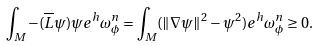Convert formula to latex. <formula><loc_0><loc_0><loc_500><loc_500>\int _ { M } - ( \overline { L } \psi ) \psi e ^ { h } \omega _ { \phi } ^ { n } = \int _ { M } ( \| \nabla \psi \| ^ { 2 } - \psi ^ { 2 } ) e ^ { h } \omega _ { \phi } ^ { n } \geq 0 .</formula> 